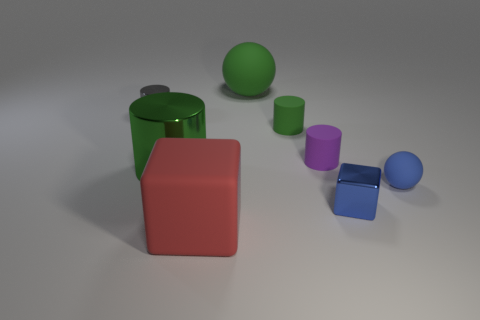How many green cylinders must be subtracted to get 1 green cylinders? 1 Subtract 1 cylinders. How many cylinders are left? 3 Add 1 big gray spheres. How many objects exist? 9 Subtract all blocks. How many objects are left? 6 Subtract 0 yellow spheres. How many objects are left? 8 Subtract all tiny yellow cylinders. Subtract all large red cubes. How many objects are left? 7 Add 4 green cylinders. How many green cylinders are left? 6 Add 2 spheres. How many spheres exist? 4 